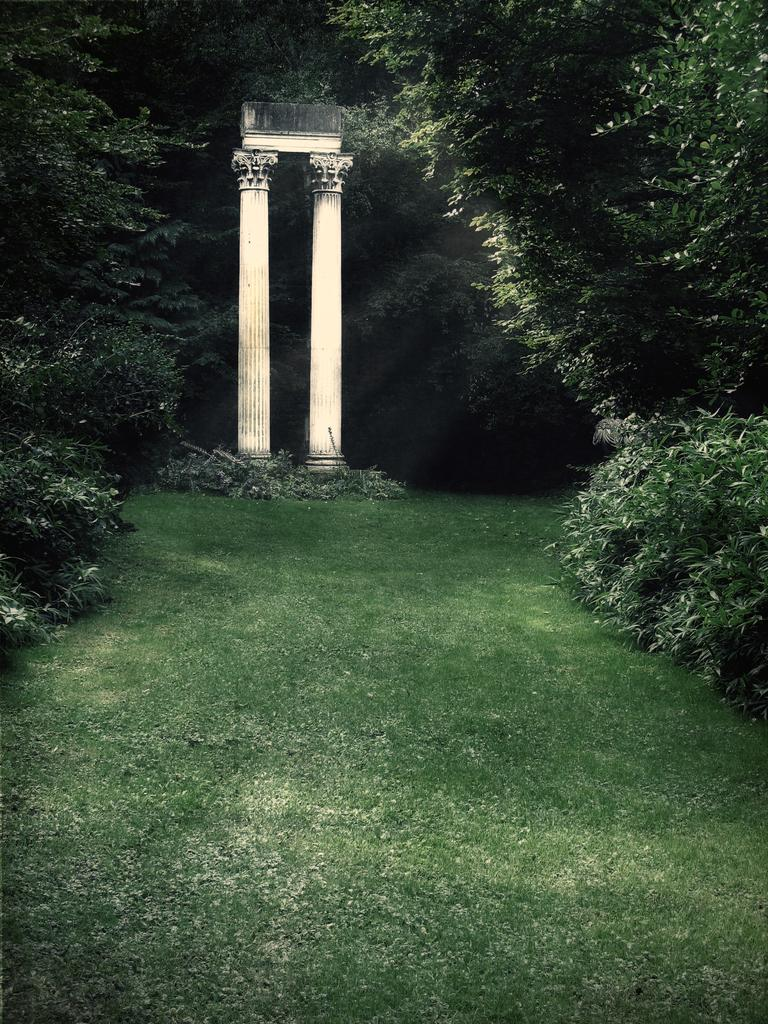What type of vegetation is at the bottom of the image? There is grass at the bottom of the image. What can be seen on the right side of the image? There are trees on the right side of the image. What can be seen on the left side of the image? There are trees on the left side of the image. What architectural features are visible in the background of the image? There are pillars in the background of the image. How many clams are visible on the grass in the image? There are no clams present in the image; it features grass, trees, and pillars. What is the birth date of the tree on the left side of the image? Trees do not have birth dates, so this information cannot be determined from the image. 